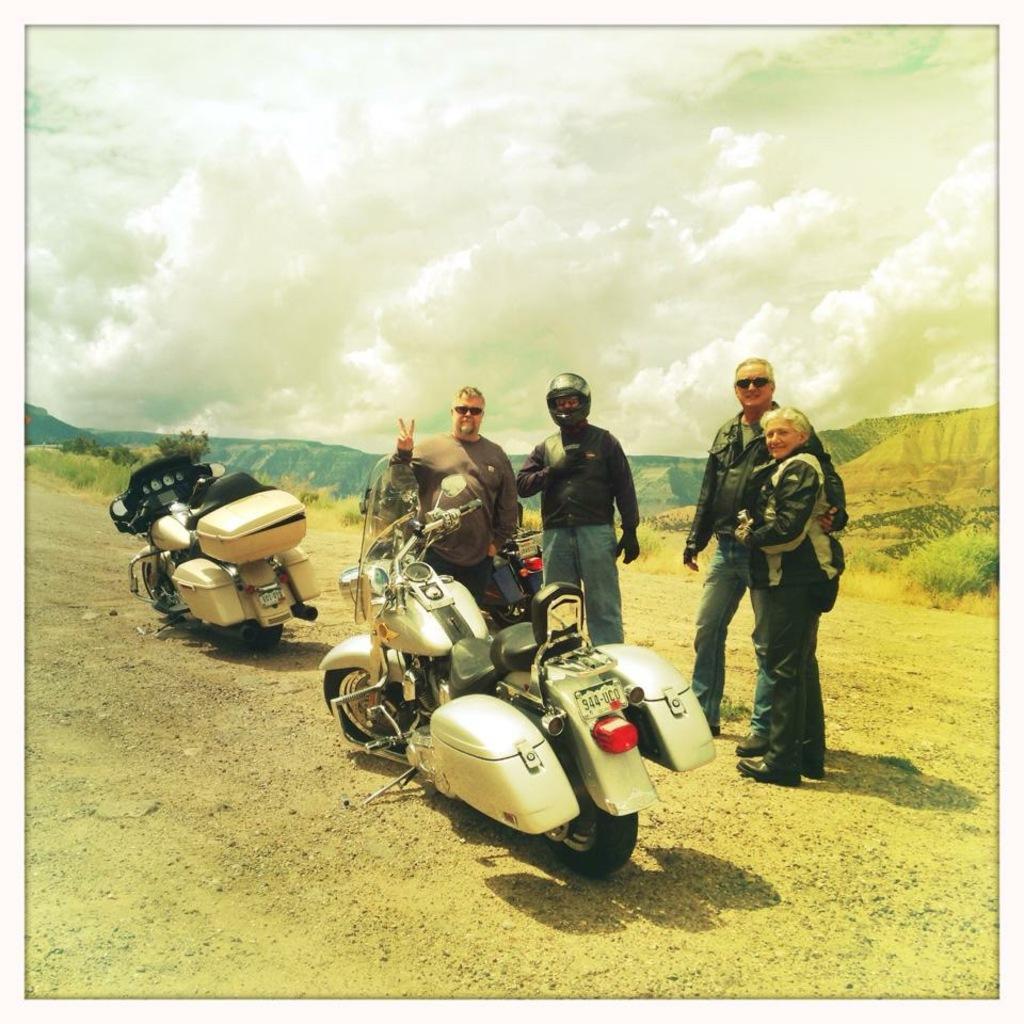In one or two sentences, can you explain what this image depicts? In this image two bikes are on the land. Right side few persons are standing on the land having some grass. Middle of the image there is a person wearing a helmet. Background there are few hills. Top of the image there is sky with some clouds. 